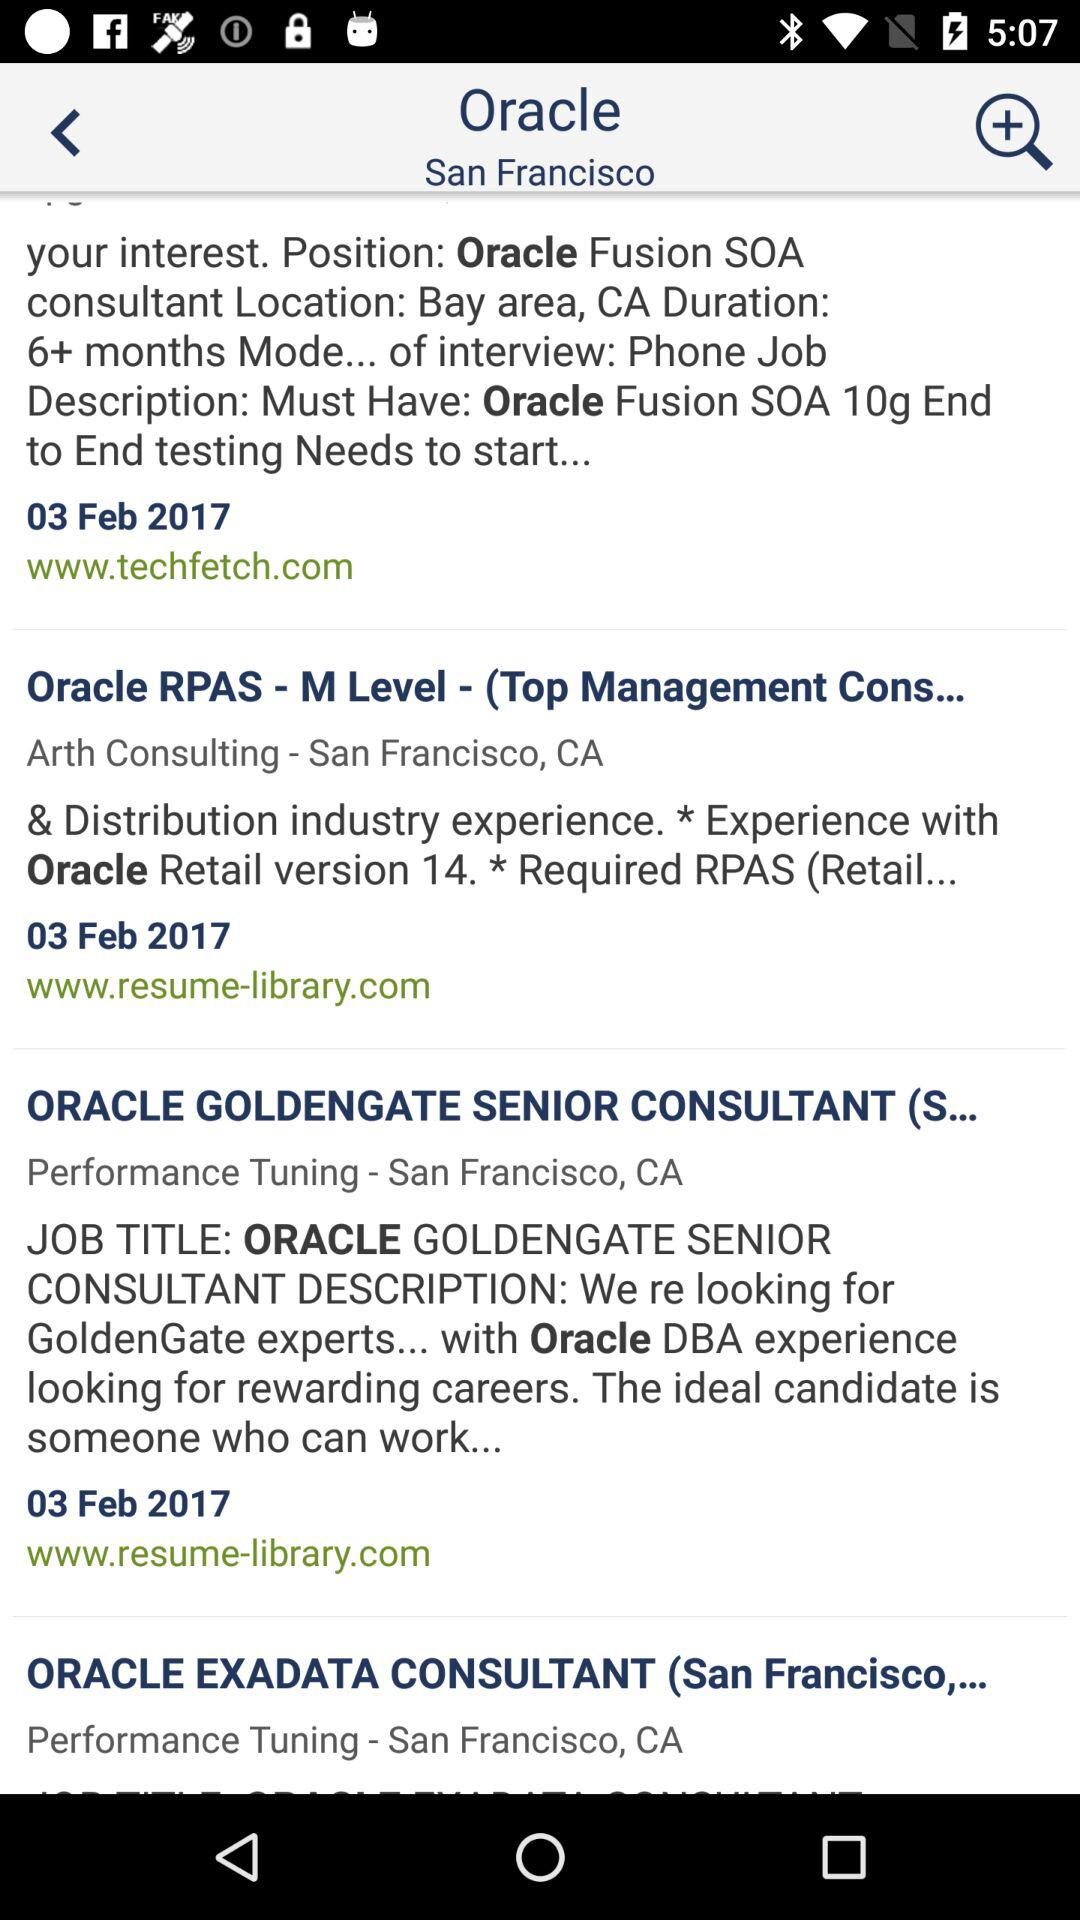What is the mentioned date? The mentioned date is February 3, 2017. 